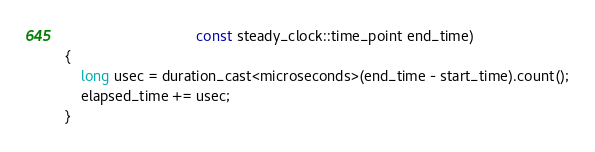Convert code to text. <code><loc_0><loc_0><loc_500><loc_500><_C++_>                                const steady_clock::time_point end_time)
{
    long usec = duration_cast<microseconds>(end_time - start_time).count();
    elapsed_time += usec;
}</code> 